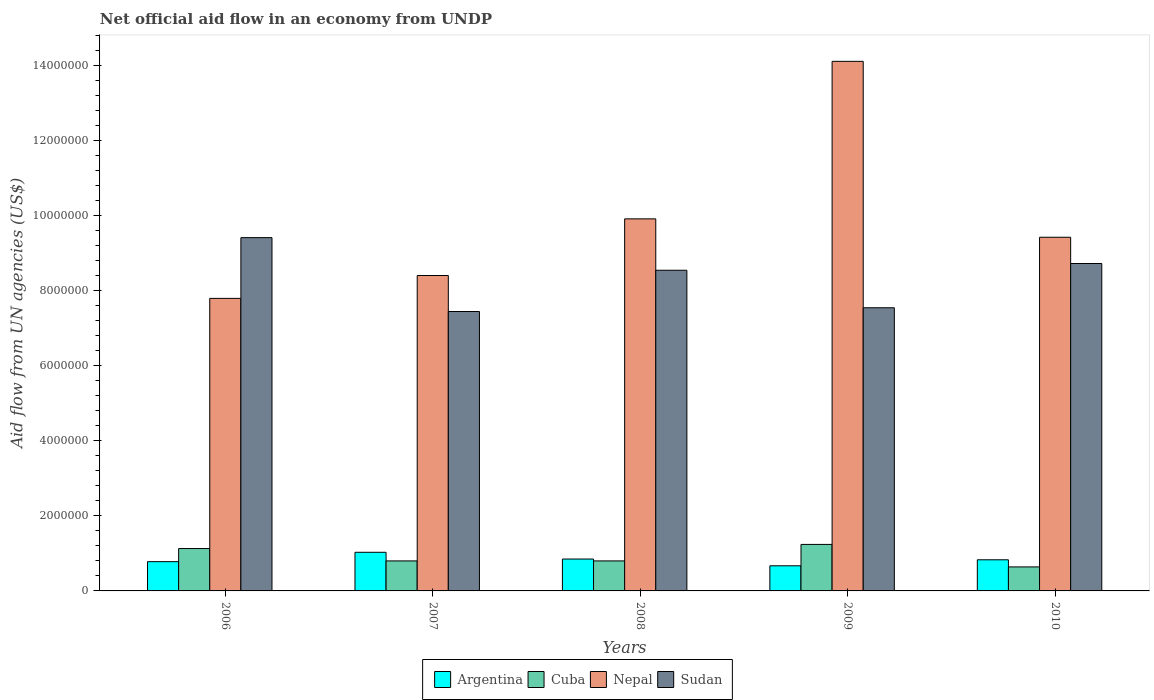How many different coloured bars are there?
Make the answer very short. 4. Are the number of bars on each tick of the X-axis equal?
Offer a very short reply. Yes. How many bars are there on the 3rd tick from the left?
Provide a short and direct response. 4. How many bars are there on the 3rd tick from the right?
Your answer should be compact. 4. What is the net official aid flow in Argentina in 2006?
Give a very brief answer. 7.80e+05. Across all years, what is the maximum net official aid flow in Cuba?
Your response must be concise. 1.24e+06. Across all years, what is the minimum net official aid flow in Argentina?
Provide a short and direct response. 6.70e+05. In which year was the net official aid flow in Nepal maximum?
Make the answer very short. 2009. In which year was the net official aid flow in Argentina minimum?
Give a very brief answer. 2009. What is the total net official aid flow in Argentina in the graph?
Give a very brief answer. 4.16e+06. What is the difference between the net official aid flow in Sudan in 2007 and that in 2009?
Ensure brevity in your answer.  -1.00e+05. What is the difference between the net official aid flow in Cuba in 2007 and the net official aid flow in Nepal in 2009?
Provide a succinct answer. -1.33e+07. What is the average net official aid flow in Sudan per year?
Provide a succinct answer. 8.34e+06. In the year 2007, what is the difference between the net official aid flow in Nepal and net official aid flow in Cuba?
Provide a succinct answer. 7.61e+06. In how many years, is the net official aid flow in Nepal greater than 8800000 US$?
Provide a succinct answer. 3. What is the ratio of the net official aid flow in Nepal in 2008 to that in 2010?
Your response must be concise. 1.05. What is the difference between the highest and the second highest net official aid flow in Nepal?
Make the answer very short. 4.20e+06. What is the difference between the highest and the lowest net official aid flow in Nepal?
Give a very brief answer. 6.32e+06. Is the sum of the net official aid flow in Nepal in 2007 and 2010 greater than the maximum net official aid flow in Cuba across all years?
Give a very brief answer. Yes. What does the 3rd bar from the left in 2008 represents?
Provide a succinct answer. Nepal. What does the 1st bar from the right in 2006 represents?
Offer a terse response. Sudan. How many bars are there?
Your response must be concise. 20. How many years are there in the graph?
Make the answer very short. 5. Are the values on the major ticks of Y-axis written in scientific E-notation?
Offer a terse response. No. Does the graph contain any zero values?
Provide a succinct answer. No. Does the graph contain grids?
Give a very brief answer. No. Where does the legend appear in the graph?
Your answer should be very brief. Bottom center. How are the legend labels stacked?
Give a very brief answer. Horizontal. What is the title of the graph?
Offer a very short reply. Net official aid flow in an economy from UNDP. Does "Sao Tome and Principe" appear as one of the legend labels in the graph?
Provide a short and direct response. No. What is the label or title of the Y-axis?
Your answer should be very brief. Aid flow from UN agencies (US$). What is the Aid flow from UN agencies (US$) in Argentina in 2006?
Provide a short and direct response. 7.80e+05. What is the Aid flow from UN agencies (US$) of Cuba in 2006?
Give a very brief answer. 1.13e+06. What is the Aid flow from UN agencies (US$) of Nepal in 2006?
Make the answer very short. 7.80e+06. What is the Aid flow from UN agencies (US$) in Sudan in 2006?
Make the answer very short. 9.42e+06. What is the Aid flow from UN agencies (US$) of Argentina in 2007?
Make the answer very short. 1.03e+06. What is the Aid flow from UN agencies (US$) of Nepal in 2007?
Provide a succinct answer. 8.41e+06. What is the Aid flow from UN agencies (US$) of Sudan in 2007?
Keep it short and to the point. 7.45e+06. What is the Aid flow from UN agencies (US$) of Argentina in 2008?
Give a very brief answer. 8.50e+05. What is the Aid flow from UN agencies (US$) of Cuba in 2008?
Provide a short and direct response. 8.00e+05. What is the Aid flow from UN agencies (US$) of Nepal in 2008?
Keep it short and to the point. 9.92e+06. What is the Aid flow from UN agencies (US$) in Sudan in 2008?
Your answer should be very brief. 8.55e+06. What is the Aid flow from UN agencies (US$) in Argentina in 2009?
Give a very brief answer. 6.70e+05. What is the Aid flow from UN agencies (US$) in Cuba in 2009?
Your response must be concise. 1.24e+06. What is the Aid flow from UN agencies (US$) in Nepal in 2009?
Offer a terse response. 1.41e+07. What is the Aid flow from UN agencies (US$) of Sudan in 2009?
Provide a short and direct response. 7.55e+06. What is the Aid flow from UN agencies (US$) in Argentina in 2010?
Ensure brevity in your answer.  8.30e+05. What is the Aid flow from UN agencies (US$) in Cuba in 2010?
Your answer should be very brief. 6.40e+05. What is the Aid flow from UN agencies (US$) in Nepal in 2010?
Your response must be concise. 9.43e+06. What is the Aid flow from UN agencies (US$) of Sudan in 2010?
Provide a short and direct response. 8.73e+06. Across all years, what is the maximum Aid flow from UN agencies (US$) of Argentina?
Your answer should be very brief. 1.03e+06. Across all years, what is the maximum Aid flow from UN agencies (US$) in Cuba?
Make the answer very short. 1.24e+06. Across all years, what is the maximum Aid flow from UN agencies (US$) of Nepal?
Offer a very short reply. 1.41e+07. Across all years, what is the maximum Aid flow from UN agencies (US$) in Sudan?
Provide a short and direct response. 9.42e+06. Across all years, what is the minimum Aid flow from UN agencies (US$) of Argentina?
Provide a short and direct response. 6.70e+05. Across all years, what is the minimum Aid flow from UN agencies (US$) of Cuba?
Your answer should be very brief. 6.40e+05. Across all years, what is the minimum Aid flow from UN agencies (US$) of Nepal?
Your answer should be very brief. 7.80e+06. Across all years, what is the minimum Aid flow from UN agencies (US$) of Sudan?
Your response must be concise. 7.45e+06. What is the total Aid flow from UN agencies (US$) of Argentina in the graph?
Make the answer very short. 4.16e+06. What is the total Aid flow from UN agencies (US$) of Cuba in the graph?
Provide a short and direct response. 4.61e+06. What is the total Aid flow from UN agencies (US$) in Nepal in the graph?
Your answer should be very brief. 4.97e+07. What is the total Aid flow from UN agencies (US$) in Sudan in the graph?
Offer a very short reply. 4.17e+07. What is the difference between the Aid flow from UN agencies (US$) of Cuba in 2006 and that in 2007?
Your answer should be compact. 3.30e+05. What is the difference between the Aid flow from UN agencies (US$) in Nepal in 2006 and that in 2007?
Your answer should be compact. -6.10e+05. What is the difference between the Aid flow from UN agencies (US$) in Sudan in 2006 and that in 2007?
Your answer should be compact. 1.97e+06. What is the difference between the Aid flow from UN agencies (US$) of Argentina in 2006 and that in 2008?
Your answer should be compact. -7.00e+04. What is the difference between the Aid flow from UN agencies (US$) in Nepal in 2006 and that in 2008?
Provide a short and direct response. -2.12e+06. What is the difference between the Aid flow from UN agencies (US$) in Sudan in 2006 and that in 2008?
Give a very brief answer. 8.70e+05. What is the difference between the Aid flow from UN agencies (US$) of Cuba in 2006 and that in 2009?
Make the answer very short. -1.10e+05. What is the difference between the Aid flow from UN agencies (US$) in Nepal in 2006 and that in 2009?
Your response must be concise. -6.32e+06. What is the difference between the Aid flow from UN agencies (US$) of Sudan in 2006 and that in 2009?
Offer a very short reply. 1.87e+06. What is the difference between the Aid flow from UN agencies (US$) in Argentina in 2006 and that in 2010?
Make the answer very short. -5.00e+04. What is the difference between the Aid flow from UN agencies (US$) of Nepal in 2006 and that in 2010?
Give a very brief answer. -1.63e+06. What is the difference between the Aid flow from UN agencies (US$) in Sudan in 2006 and that in 2010?
Your response must be concise. 6.90e+05. What is the difference between the Aid flow from UN agencies (US$) of Cuba in 2007 and that in 2008?
Your answer should be compact. 0. What is the difference between the Aid flow from UN agencies (US$) in Nepal in 2007 and that in 2008?
Provide a succinct answer. -1.51e+06. What is the difference between the Aid flow from UN agencies (US$) of Sudan in 2007 and that in 2008?
Offer a very short reply. -1.10e+06. What is the difference between the Aid flow from UN agencies (US$) in Cuba in 2007 and that in 2009?
Your answer should be very brief. -4.40e+05. What is the difference between the Aid flow from UN agencies (US$) in Nepal in 2007 and that in 2009?
Your answer should be compact. -5.71e+06. What is the difference between the Aid flow from UN agencies (US$) of Cuba in 2007 and that in 2010?
Your answer should be compact. 1.60e+05. What is the difference between the Aid flow from UN agencies (US$) of Nepal in 2007 and that in 2010?
Provide a short and direct response. -1.02e+06. What is the difference between the Aid flow from UN agencies (US$) in Sudan in 2007 and that in 2010?
Your answer should be very brief. -1.28e+06. What is the difference between the Aid flow from UN agencies (US$) in Cuba in 2008 and that in 2009?
Your answer should be compact. -4.40e+05. What is the difference between the Aid flow from UN agencies (US$) in Nepal in 2008 and that in 2009?
Offer a terse response. -4.20e+06. What is the difference between the Aid flow from UN agencies (US$) in Argentina in 2008 and that in 2010?
Your answer should be compact. 2.00e+04. What is the difference between the Aid flow from UN agencies (US$) in Cuba in 2008 and that in 2010?
Your answer should be very brief. 1.60e+05. What is the difference between the Aid flow from UN agencies (US$) in Nepal in 2008 and that in 2010?
Offer a very short reply. 4.90e+05. What is the difference between the Aid flow from UN agencies (US$) of Cuba in 2009 and that in 2010?
Your response must be concise. 6.00e+05. What is the difference between the Aid flow from UN agencies (US$) in Nepal in 2009 and that in 2010?
Keep it short and to the point. 4.69e+06. What is the difference between the Aid flow from UN agencies (US$) in Sudan in 2009 and that in 2010?
Give a very brief answer. -1.18e+06. What is the difference between the Aid flow from UN agencies (US$) of Argentina in 2006 and the Aid flow from UN agencies (US$) of Nepal in 2007?
Ensure brevity in your answer.  -7.63e+06. What is the difference between the Aid flow from UN agencies (US$) in Argentina in 2006 and the Aid flow from UN agencies (US$) in Sudan in 2007?
Offer a terse response. -6.67e+06. What is the difference between the Aid flow from UN agencies (US$) in Cuba in 2006 and the Aid flow from UN agencies (US$) in Nepal in 2007?
Offer a terse response. -7.28e+06. What is the difference between the Aid flow from UN agencies (US$) in Cuba in 2006 and the Aid flow from UN agencies (US$) in Sudan in 2007?
Offer a very short reply. -6.32e+06. What is the difference between the Aid flow from UN agencies (US$) of Argentina in 2006 and the Aid flow from UN agencies (US$) of Nepal in 2008?
Keep it short and to the point. -9.14e+06. What is the difference between the Aid flow from UN agencies (US$) of Argentina in 2006 and the Aid flow from UN agencies (US$) of Sudan in 2008?
Provide a short and direct response. -7.77e+06. What is the difference between the Aid flow from UN agencies (US$) of Cuba in 2006 and the Aid flow from UN agencies (US$) of Nepal in 2008?
Keep it short and to the point. -8.79e+06. What is the difference between the Aid flow from UN agencies (US$) of Cuba in 2006 and the Aid flow from UN agencies (US$) of Sudan in 2008?
Keep it short and to the point. -7.42e+06. What is the difference between the Aid flow from UN agencies (US$) in Nepal in 2006 and the Aid flow from UN agencies (US$) in Sudan in 2008?
Your answer should be compact. -7.50e+05. What is the difference between the Aid flow from UN agencies (US$) of Argentina in 2006 and the Aid flow from UN agencies (US$) of Cuba in 2009?
Keep it short and to the point. -4.60e+05. What is the difference between the Aid flow from UN agencies (US$) of Argentina in 2006 and the Aid flow from UN agencies (US$) of Nepal in 2009?
Your answer should be compact. -1.33e+07. What is the difference between the Aid flow from UN agencies (US$) of Argentina in 2006 and the Aid flow from UN agencies (US$) of Sudan in 2009?
Make the answer very short. -6.77e+06. What is the difference between the Aid flow from UN agencies (US$) of Cuba in 2006 and the Aid flow from UN agencies (US$) of Nepal in 2009?
Your response must be concise. -1.30e+07. What is the difference between the Aid flow from UN agencies (US$) in Cuba in 2006 and the Aid flow from UN agencies (US$) in Sudan in 2009?
Provide a short and direct response. -6.42e+06. What is the difference between the Aid flow from UN agencies (US$) in Nepal in 2006 and the Aid flow from UN agencies (US$) in Sudan in 2009?
Your response must be concise. 2.50e+05. What is the difference between the Aid flow from UN agencies (US$) in Argentina in 2006 and the Aid flow from UN agencies (US$) in Nepal in 2010?
Your answer should be compact. -8.65e+06. What is the difference between the Aid flow from UN agencies (US$) in Argentina in 2006 and the Aid flow from UN agencies (US$) in Sudan in 2010?
Keep it short and to the point. -7.95e+06. What is the difference between the Aid flow from UN agencies (US$) of Cuba in 2006 and the Aid flow from UN agencies (US$) of Nepal in 2010?
Your answer should be compact. -8.30e+06. What is the difference between the Aid flow from UN agencies (US$) of Cuba in 2006 and the Aid flow from UN agencies (US$) of Sudan in 2010?
Your answer should be very brief. -7.60e+06. What is the difference between the Aid flow from UN agencies (US$) of Nepal in 2006 and the Aid flow from UN agencies (US$) of Sudan in 2010?
Your answer should be very brief. -9.30e+05. What is the difference between the Aid flow from UN agencies (US$) of Argentina in 2007 and the Aid flow from UN agencies (US$) of Nepal in 2008?
Provide a short and direct response. -8.89e+06. What is the difference between the Aid flow from UN agencies (US$) of Argentina in 2007 and the Aid flow from UN agencies (US$) of Sudan in 2008?
Give a very brief answer. -7.52e+06. What is the difference between the Aid flow from UN agencies (US$) in Cuba in 2007 and the Aid flow from UN agencies (US$) in Nepal in 2008?
Keep it short and to the point. -9.12e+06. What is the difference between the Aid flow from UN agencies (US$) in Cuba in 2007 and the Aid flow from UN agencies (US$) in Sudan in 2008?
Your response must be concise. -7.75e+06. What is the difference between the Aid flow from UN agencies (US$) in Nepal in 2007 and the Aid flow from UN agencies (US$) in Sudan in 2008?
Provide a short and direct response. -1.40e+05. What is the difference between the Aid flow from UN agencies (US$) of Argentina in 2007 and the Aid flow from UN agencies (US$) of Cuba in 2009?
Provide a short and direct response. -2.10e+05. What is the difference between the Aid flow from UN agencies (US$) of Argentina in 2007 and the Aid flow from UN agencies (US$) of Nepal in 2009?
Your answer should be very brief. -1.31e+07. What is the difference between the Aid flow from UN agencies (US$) in Argentina in 2007 and the Aid flow from UN agencies (US$) in Sudan in 2009?
Your response must be concise. -6.52e+06. What is the difference between the Aid flow from UN agencies (US$) in Cuba in 2007 and the Aid flow from UN agencies (US$) in Nepal in 2009?
Keep it short and to the point. -1.33e+07. What is the difference between the Aid flow from UN agencies (US$) in Cuba in 2007 and the Aid flow from UN agencies (US$) in Sudan in 2009?
Make the answer very short. -6.75e+06. What is the difference between the Aid flow from UN agencies (US$) in Nepal in 2007 and the Aid flow from UN agencies (US$) in Sudan in 2009?
Your answer should be very brief. 8.60e+05. What is the difference between the Aid flow from UN agencies (US$) in Argentina in 2007 and the Aid flow from UN agencies (US$) in Nepal in 2010?
Offer a very short reply. -8.40e+06. What is the difference between the Aid flow from UN agencies (US$) in Argentina in 2007 and the Aid flow from UN agencies (US$) in Sudan in 2010?
Your answer should be compact. -7.70e+06. What is the difference between the Aid flow from UN agencies (US$) of Cuba in 2007 and the Aid flow from UN agencies (US$) of Nepal in 2010?
Keep it short and to the point. -8.63e+06. What is the difference between the Aid flow from UN agencies (US$) of Cuba in 2007 and the Aid flow from UN agencies (US$) of Sudan in 2010?
Keep it short and to the point. -7.93e+06. What is the difference between the Aid flow from UN agencies (US$) in Nepal in 2007 and the Aid flow from UN agencies (US$) in Sudan in 2010?
Make the answer very short. -3.20e+05. What is the difference between the Aid flow from UN agencies (US$) of Argentina in 2008 and the Aid flow from UN agencies (US$) of Cuba in 2009?
Keep it short and to the point. -3.90e+05. What is the difference between the Aid flow from UN agencies (US$) of Argentina in 2008 and the Aid flow from UN agencies (US$) of Nepal in 2009?
Your answer should be compact. -1.33e+07. What is the difference between the Aid flow from UN agencies (US$) in Argentina in 2008 and the Aid flow from UN agencies (US$) in Sudan in 2009?
Offer a very short reply. -6.70e+06. What is the difference between the Aid flow from UN agencies (US$) of Cuba in 2008 and the Aid flow from UN agencies (US$) of Nepal in 2009?
Provide a short and direct response. -1.33e+07. What is the difference between the Aid flow from UN agencies (US$) of Cuba in 2008 and the Aid flow from UN agencies (US$) of Sudan in 2009?
Your answer should be very brief. -6.75e+06. What is the difference between the Aid flow from UN agencies (US$) in Nepal in 2008 and the Aid flow from UN agencies (US$) in Sudan in 2009?
Your answer should be compact. 2.37e+06. What is the difference between the Aid flow from UN agencies (US$) of Argentina in 2008 and the Aid flow from UN agencies (US$) of Nepal in 2010?
Your response must be concise. -8.58e+06. What is the difference between the Aid flow from UN agencies (US$) of Argentina in 2008 and the Aid flow from UN agencies (US$) of Sudan in 2010?
Make the answer very short. -7.88e+06. What is the difference between the Aid flow from UN agencies (US$) in Cuba in 2008 and the Aid flow from UN agencies (US$) in Nepal in 2010?
Provide a short and direct response. -8.63e+06. What is the difference between the Aid flow from UN agencies (US$) of Cuba in 2008 and the Aid flow from UN agencies (US$) of Sudan in 2010?
Offer a terse response. -7.93e+06. What is the difference between the Aid flow from UN agencies (US$) of Nepal in 2008 and the Aid flow from UN agencies (US$) of Sudan in 2010?
Offer a very short reply. 1.19e+06. What is the difference between the Aid flow from UN agencies (US$) in Argentina in 2009 and the Aid flow from UN agencies (US$) in Nepal in 2010?
Offer a very short reply. -8.76e+06. What is the difference between the Aid flow from UN agencies (US$) of Argentina in 2009 and the Aid flow from UN agencies (US$) of Sudan in 2010?
Offer a very short reply. -8.06e+06. What is the difference between the Aid flow from UN agencies (US$) in Cuba in 2009 and the Aid flow from UN agencies (US$) in Nepal in 2010?
Keep it short and to the point. -8.19e+06. What is the difference between the Aid flow from UN agencies (US$) of Cuba in 2009 and the Aid flow from UN agencies (US$) of Sudan in 2010?
Offer a terse response. -7.49e+06. What is the difference between the Aid flow from UN agencies (US$) in Nepal in 2009 and the Aid flow from UN agencies (US$) in Sudan in 2010?
Your response must be concise. 5.39e+06. What is the average Aid flow from UN agencies (US$) in Argentina per year?
Your answer should be compact. 8.32e+05. What is the average Aid flow from UN agencies (US$) of Cuba per year?
Offer a very short reply. 9.22e+05. What is the average Aid flow from UN agencies (US$) in Nepal per year?
Offer a terse response. 9.94e+06. What is the average Aid flow from UN agencies (US$) in Sudan per year?
Your answer should be very brief. 8.34e+06. In the year 2006, what is the difference between the Aid flow from UN agencies (US$) of Argentina and Aid flow from UN agencies (US$) of Cuba?
Offer a terse response. -3.50e+05. In the year 2006, what is the difference between the Aid flow from UN agencies (US$) in Argentina and Aid flow from UN agencies (US$) in Nepal?
Make the answer very short. -7.02e+06. In the year 2006, what is the difference between the Aid flow from UN agencies (US$) in Argentina and Aid flow from UN agencies (US$) in Sudan?
Keep it short and to the point. -8.64e+06. In the year 2006, what is the difference between the Aid flow from UN agencies (US$) of Cuba and Aid flow from UN agencies (US$) of Nepal?
Make the answer very short. -6.67e+06. In the year 2006, what is the difference between the Aid flow from UN agencies (US$) of Cuba and Aid flow from UN agencies (US$) of Sudan?
Your response must be concise. -8.29e+06. In the year 2006, what is the difference between the Aid flow from UN agencies (US$) in Nepal and Aid flow from UN agencies (US$) in Sudan?
Keep it short and to the point. -1.62e+06. In the year 2007, what is the difference between the Aid flow from UN agencies (US$) of Argentina and Aid flow from UN agencies (US$) of Nepal?
Ensure brevity in your answer.  -7.38e+06. In the year 2007, what is the difference between the Aid flow from UN agencies (US$) in Argentina and Aid flow from UN agencies (US$) in Sudan?
Keep it short and to the point. -6.42e+06. In the year 2007, what is the difference between the Aid flow from UN agencies (US$) of Cuba and Aid flow from UN agencies (US$) of Nepal?
Make the answer very short. -7.61e+06. In the year 2007, what is the difference between the Aid flow from UN agencies (US$) of Cuba and Aid flow from UN agencies (US$) of Sudan?
Your response must be concise. -6.65e+06. In the year 2007, what is the difference between the Aid flow from UN agencies (US$) in Nepal and Aid flow from UN agencies (US$) in Sudan?
Offer a very short reply. 9.60e+05. In the year 2008, what is the difference between the Aid flow from UN agencies (US$) of Argentina and Aid flow from UN agencies (US$) of Cuba?
Your response must be concise. 5.00e+04. In the year 2008, what is the difference between the Aid flow from UN agencies (US$) of Argentina and Aid flow from UN agencies (US$) of Nepal?
Give a very brief answer. -9.07e+06. In the year 2008, what is the difference between the Aid flow from UN agencies (US$) in Argentina and Aid flow from UN agencies (US$) in Sudan?
Offer a very short reply. -7.70e+06. In the year 2008, what is the difference between the Aid flow from UN agencies (US$) in Cuba and Aid flow from UN agencies (US$) in Nepal?
Your answer should be very brief. -9.12e+06. In the year 2008, what is the difference between the Aid flow from UN agencies (US$) of Cuba and Aid flow from UN agencies (US$) of Sudan?
Provide a short and direct response. -7.75e+06. In the year 2008, what is the difference between the Aid flow from UN agencies (US$) in Nepal and Aid flow from UN agencies (US$) in Sudan?
Give a very brief answer. 1.37e+06. In the year 2009, what is the difference between the Aid flow from UN agencies (US$) of Argentina and Aid flow from UN agencies (US$) of Cuba?
Your answer should be very brief. -5.70e+05. In the year 2009, what is the difference between the Aid flow from UN agencies (US$) in Argentina and Aid flow from UN agencies (US$) in Nepal?
Make the answer very short. -1.34e+07. In the year 2009, what is the difference between the Aid flow from UN agencies (US$) in Argentina and Aid flow from UN agencies (US$) in Sudan?
Your answer should be compact. -6.88e+06. In the year 2009, what is the difference between the Aid flow from UN agencies (US$) of Cuba and Aid flow from UN agencies (US$) of Nepal?
Provide a succinct answer. -1.29e+07. In the year 2009, what is the difference between the Aid flow from UN agencies (US$) in Cuba and Aid flow from UN agencies (US$) in Sudan?
Your answer should be compact. -6.31e+06. In the year 2009, what is the difference between the Aid flow from UN agencies (US$) of Nepal and Aid flow from UN agencies (US$) of Sudan?
Offer a terse response. 6.57e+06. In the year 2010, what is the difference between the Aid flow from UN agencies (US$) in Argentina and Aid flow from UN agencies (US$) in Cuba?
Your answer should be very brief. 1.90e+05. In the year 2010, what is the difference between the Aid flow from UN agencies (US$) of Argentina and Aid flow from UN agencies (US$) of Nepal?
Provide a succinct answer. -8.60e+06. In the year 2010, what is the difference between the Aid flow from UN agencies (US$) of Argentina and Aid flow from UN agencies (US$) of Sudan?
Offer a very short reply. -7.90e+06. In the year 2010, what is the difference between the Aid flow from UN agencies (US$) of Cuba and Aid flow from UN agencies (US$) of Nepal?
Your answer should be compact. -8.79e+06. In the year 2010, what is the difference between the Aid flow from UN agencies (US$) in Cuba and Aid flow from UN agencies (US$) in Sudan?
Offer a very short reply. -8.09e+06. In the year 2010, what is the difference between the Aid flow from UN agencies (US$) in Nepal and Aid flow from UN agencies (US$) in Sudan?
Give a very brief answer. 7.00e+05. What is the ratio of the Aid flow from UN agencies (US$) of Argentina in 2006 to that in 2007?
Give a very brief answer. 0.76. What is the ratio of the Aid flow from UN agencies (US$) of Cuba in 2006 to that in 2007?
Your answer should be compact. 1.41. What is the ratio of the Aid flow from UN agencies (US$) in Nepal in 2006 to that in 2007?
Provide a short and direct response. 0.93. What is the ratio of the Aid flow from UN agencies (US$) in Sudan in 2006 to that in 2007?
Offer a very short reply. 1.26. What is the ratio of the Aid flow from UN agencies (US$) in Argentina in 2006 to that in 2008?
Provide a succinct answer. 0.92. What is the ratio of the Aid flow from UN agencies (US$) in Cuba in 2006 to that in 2008?
Give a very brief answer. 1.41. What is the ratio of the Aid flow from UN agencies (US$) in Nepal in 2006 to that in 2008?
Make the answer very short. 0.79. What is the ratio of the Aid flow from UN agencies (US$) of Sudan in 2006 to that in 2008?
Make the answer very short. 1.1. What is the ratio of the Aid flow from UN agencies (US$) in Argentina in 2006 to that in 2009?
Provide a succinct answer. 1.16. What is the ratio of the Aid flow from UN agencies (US$) in Cuba in 2006 to that in 2009?
Your answer should be compact. 0.91. What is the ratio of the Aid flow from UN agencies (US$) in Nepal in 2006 to that in 2009?
Offer a very short reply. 0.55. What is the ratio of the Aid flow from UN agencies (US$) of Sudan in 2006 to that in 2009?
Offer a very short reply. 1.25. What is the ratio of the Aid flow from UN agencies (US$) in Argentina in 2006 to that in 2010?
Offer a very short reply. 0.94. What is the ratio of the Aid flow from UN agencies (US$) of Cuba in 2006 to that in 2010?
Offer a terse response. 1.77. What is the ratio of the Aid flow from UN agencies (US$) in Nepal in 2006 to that in 2010?
Offer a terse response. 0.83. What is the ratio of the Aid flow from UN agencies (US$) in Sudan in 2006 to that in 2010?
Offer a terse response. 1.08. What is the ratio of the Aid flow from UN agencies (US$) of Argentina in 2007 to that in 2008?
Your response must be concise. 1.21. What is the ratio of the Aid flow from UN agencies (US$) of Cuba in 2007 to that in 2008?
Make the answer very short. 1. What is the ratio of the Aid flow from UN agencies (US$) in Nepal in 2007 to that in 2008?
Your answer should be very brief. 0.85. What is the ratio of the Aid flow from UN agencies (US$) in Sudan in 2007 to that in 2008?
Provide a succinct answer. 0.87. What is the ratio of the Aid flow from UN agencies (US$) in Argentina in 2007 to that in 2009?
Offer a very short reply. 1.54. What is the ratio of the Aid flow from UN agencies (US$) in Cuba in 2007 to that in 2009?
Provide a short and direct response. 0.65. What is the ratio of the Aid flow from UN agencies (US$) of Nepal in 2007 to that in 2009?
Your answer should be very brief. 0.6. What is the ratio of the Aid flow from UN agencies (US$) of Argentina in 2007 to that in 2010?
Provide a succinct answer. 1.24. What is the ratio of the Aid flow from UN agencies (US$) of Nepal in 2007 to that in 2010?
Give a very brief answer. 0.89. What is the ratio of the Aid flow from UN agencies (US$) of Sudan in 2007 to that in 2010?
Give a very brief answer. 0.85. What is the ratio of the Aid flow from UN agencies (US$) of Argentina in 2008 to that in 2009?
Offer a terse response. 1.27. What is the ratio of the Aid flow from UN agencies (US$) of Cuba in 2008 to that in 2009?
Provide a short and direct response. 0.65. What is the ratio of the Aid flow from UN agencies (US$) in Nepal in 2008 to that in 2009?
Provide a short and direct response. 0.7. What is the ratio of the Aid flow from UN agencies (US$) in Sudan in 2008 to that in 2009?
Your answer should be very brief. 1.13. What is the ratio of the Aid flow from UN agencies (US$) of Argentina in 2008 to that in 2010?
Give a very brief answer. 1.02. What is the ratio of the Aid flow from UN agencies (US$) in Cuba in 2008 to that in 2010?
Offer a terse response. 1.25. What is the ratio of the Aid flow from UN agencies (US$) in Nepal in 2008 to that in 2010?
Your answer should be very brief. 1.05. What is the ratio of the Aid flow from UN agencies (US$) in Sudan in 2008 to that in 2010?
Give a very brief answer. 0.98. What is the ratio of the Aid flow from UN agencies (US$) in Argentina in 2009 to that in 2010?
Give a very brief answer. 0.81. What is the ratio of the Aid flow from UN agencies (US$) in Cuba in 2009 to that in 2010?
Your answer should be very brief. 1.94. What is the ratio of the Aid flow from UN agencies (US$) in Nepal in 2009 to that in 2010?
Your answer should be compact. 1.5. What is the ratio of the Aid flow from UN agencies (US$) in Sudan in 2009 to that in 2010?
Ensure brevity in your answer.  0.86. What is the difference between the highest and the second highest Aid flow from UN agencies (US$) in Cuba?
Keep it short and to the point. 1.10e+05. What is the difference between the highest and the second highest Aid flow from UN agencies (US$) of Nepal?
Offer a very short reply. 4.20e+06. What is the difference between the highest and the second highest Aid flow from UN agencies (US$) of Sudan?
Provide a short and direct response. 6.90e+05. What is the difference between the highest and the lowest Aid flow from UN agencies (US$) in Argentina?
Give a very brief answer. 3.60e+05. What is the difference between the highest and the lowest Aid flow from UN agencies (US$) in Cuba?
Make the answer very short. 6.00e+05. What is the difference between the highest and the lowest Aid flow from UN agencies (US$) in Nepal?
Your answer should be compact. 6.32e+06. What is the difference between the highest and the lowest Aid flow from UN agencies (US$) of Sudan?
Offer a terse response. 1.97e+06. 